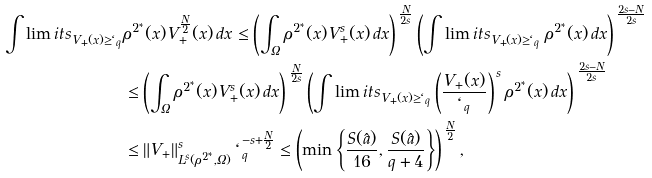<formula> <loc_0><loc_0><loc_500><loc_500>\int \lim i t s _ { V _ { + } ( x ) \geq \ell _ { q } } & \rho ^ { 2 ^ { * } } ( x ) V _ { + } ^ { \frac { N } { 2 } } ( x ) \, d x \leq \left ( \int _ { \Omega } \rho ^ { 2 ^ { * } } ( x ) V _ { + } ^ { s } ( x ) \, d x \right ) ^ { \, \frac { N } { 2 s } } \left ( \int \lim i t s _ { V _ { + } ( x ) \geq \ell _ { q } } \, \rho ^ { 2 ^ { * } } ( x ) \, d x \right ) ^ { \, \frac { 2 s - N } { 2 s } } \\ & \leq \left ( \int _ { \Omega } \rho ^ { 2 ^ { * } } ( x ) V _ { + } ^ { s } ( x ) \, d x \right ) ^ { \, \frac { N } { 2 s } } \left ( \int \lim i t s _ { V _ { + } ( x ) \geq \ell _ { q } } \left ( \frac { V _ { + } ( x ) } { \ell _ { q } } \right ) ^ { \, s } \rho ^ { 2 ^ { * } } ( x ) \, d x \right ) ^ { \, \frac { 2 s - N } { 2 s } } \\ & \leq \| V _ { + } \| _ { L ^ { s } ( \rho ^ { 2 ^ { * } } , \Omega ) } ^ { s } \, \ell _ { q } ^ { - s + \frac { N } { 2 } } \leq \left ( \min \left \{ \frac { S ( \hat { a } ) } { 1 6 } , \frac { S ( \hat { a } ) } { q + 4 } \right \} \right ) ^ { \, \frac { N } { 2 } } ,</formula> 